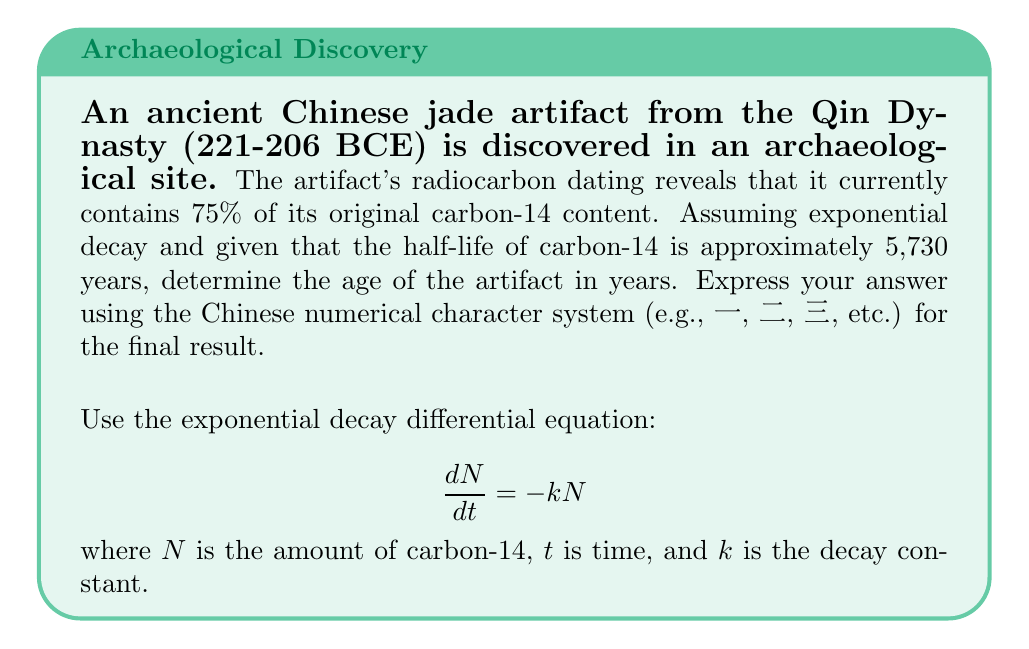Give your solution to this math problem. Let's approach this step-by-step:

1) The exponential decay equation is:
   $$N(t) = N_0e^{-kt}$$
   where $N_0$ is the initial amount, and $N(t)$ is the amount at time $t$.

2) We know that 75% of the original content remains, so:
   $$\frac{N(t)}{N_0} = 0.75$$

3) Substituting this into our equation:
   $$0.75 = e^{-kt}$$

4) Taking the natural log of both sides:
   $$\ln(0.75) = -kt$$

5) To find $k$, we can use the half-life formula:
   $$T_{1/2} = \frac{\ln(2)}{k}$$

6) Rearranging to solve for $k$:
   $$k = \frac{\ln(2)}{T_{1/2}} = \frac{\ln(2)}{5730} \approx 0.000121$$

7) Now we can solve for $t$:
   $$t = -\frac{\ln(0.75)}{k} = -\frac{\ln(0.75)}{0.000121} \approx 2384.95$$

8) Rounding to the nearest year: 2,385 years

9) Converting to Chinese numerical characters:
   二千三百八十五年
Answer: 二千三百八十五年 